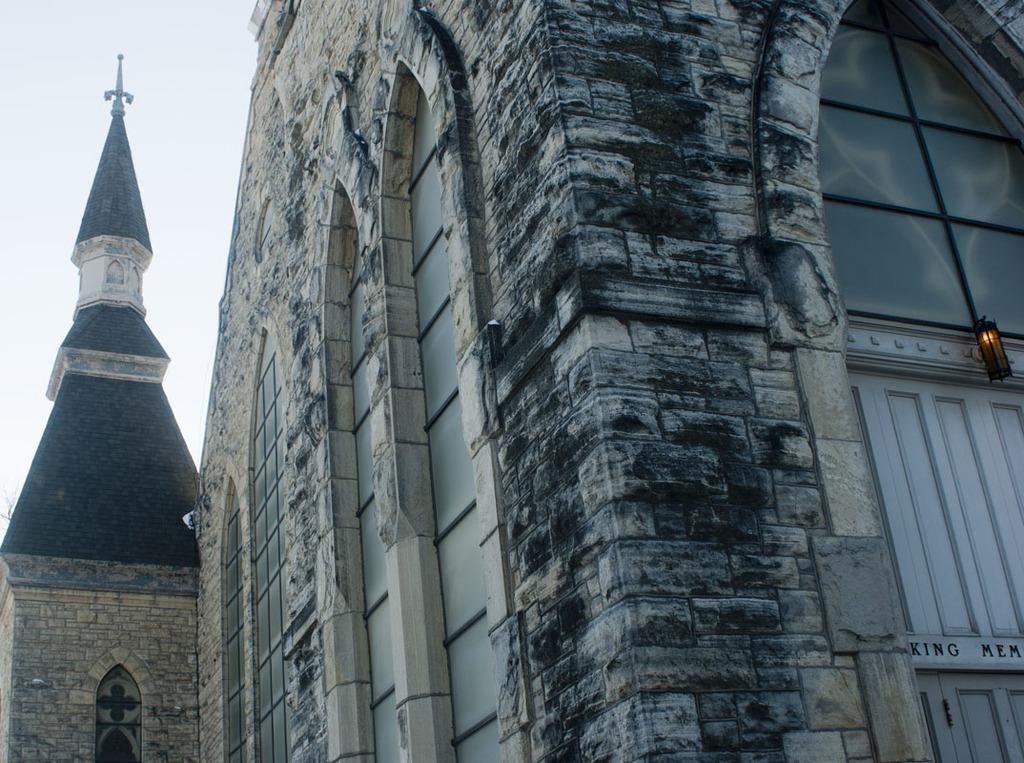What type of structure is present in the image? There is a building in the image. Can you describe any objects near the building? There is a lamp on the right side of the image. What part of the natural environment is visible in the image? The sky is visible at the left top of the image. What type of underwear is hanging on the border of the image? There is no underwear or border present in the image. 